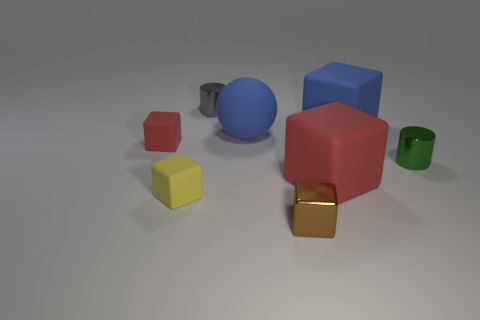Is the color of the large block behind the small green object the same as the large rubber sphere?
Your answer should be compact. Yes. There is a small object that is behind the blue matte cube; is it the same shape as the metal object that is to the right of the large red rubber object?
Offer a terse response. Yes. There is a blue object that is to the left of the big blue matte block; how big is it?
Make the answer very short. Large. There is a red matte thing right of the cylinder to the left of the tiny green cylinder; how big is it?
Your answer should be very brief. Large. Is the number of small green cylinders greater than the number of small cubes?
Keep it short and to the point. No. Is the number of blue matte things that are behind the large matte sphere greater than the number of blue balls in front of the green thing?
Your answer should be compact. Yes. What size is the rubber thing that is behind the green shiny cylinder and right of the small brown block?
Keep it short and to the point. Large. How many green cylinders have the same size as the yellow object?
Provide a short and direct response. 1. There is a big block that is the same color as the matte ball; what material is it?
Offer a terse response. Rubber. There is a large blue matte thing on the right side of the matte sphere; does it have the same shape as the large red thing?
Your answer should be very brief. Yes. 